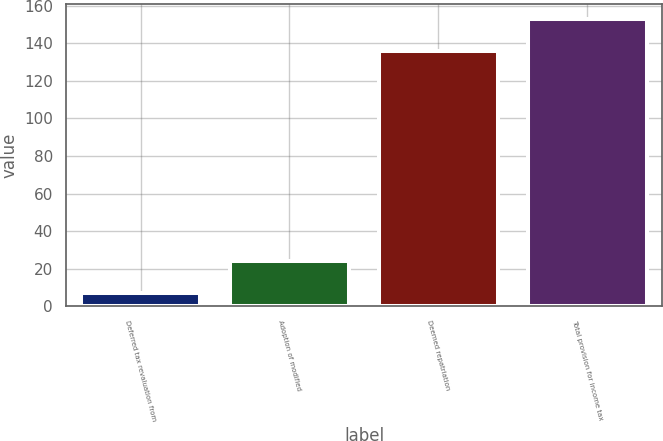Convert chart to OTSL. <chart><loc_0><loc_0><loc_500><loc_500><bar_chart><fcel>Deferred tax revaluation from<fcel>Adoption of modified<fcel>Deemed repatriation<fcel>Total provision for income tax<nl><fcel>7<fcel>24<fcel>136<fcel>153<nl></chart> 